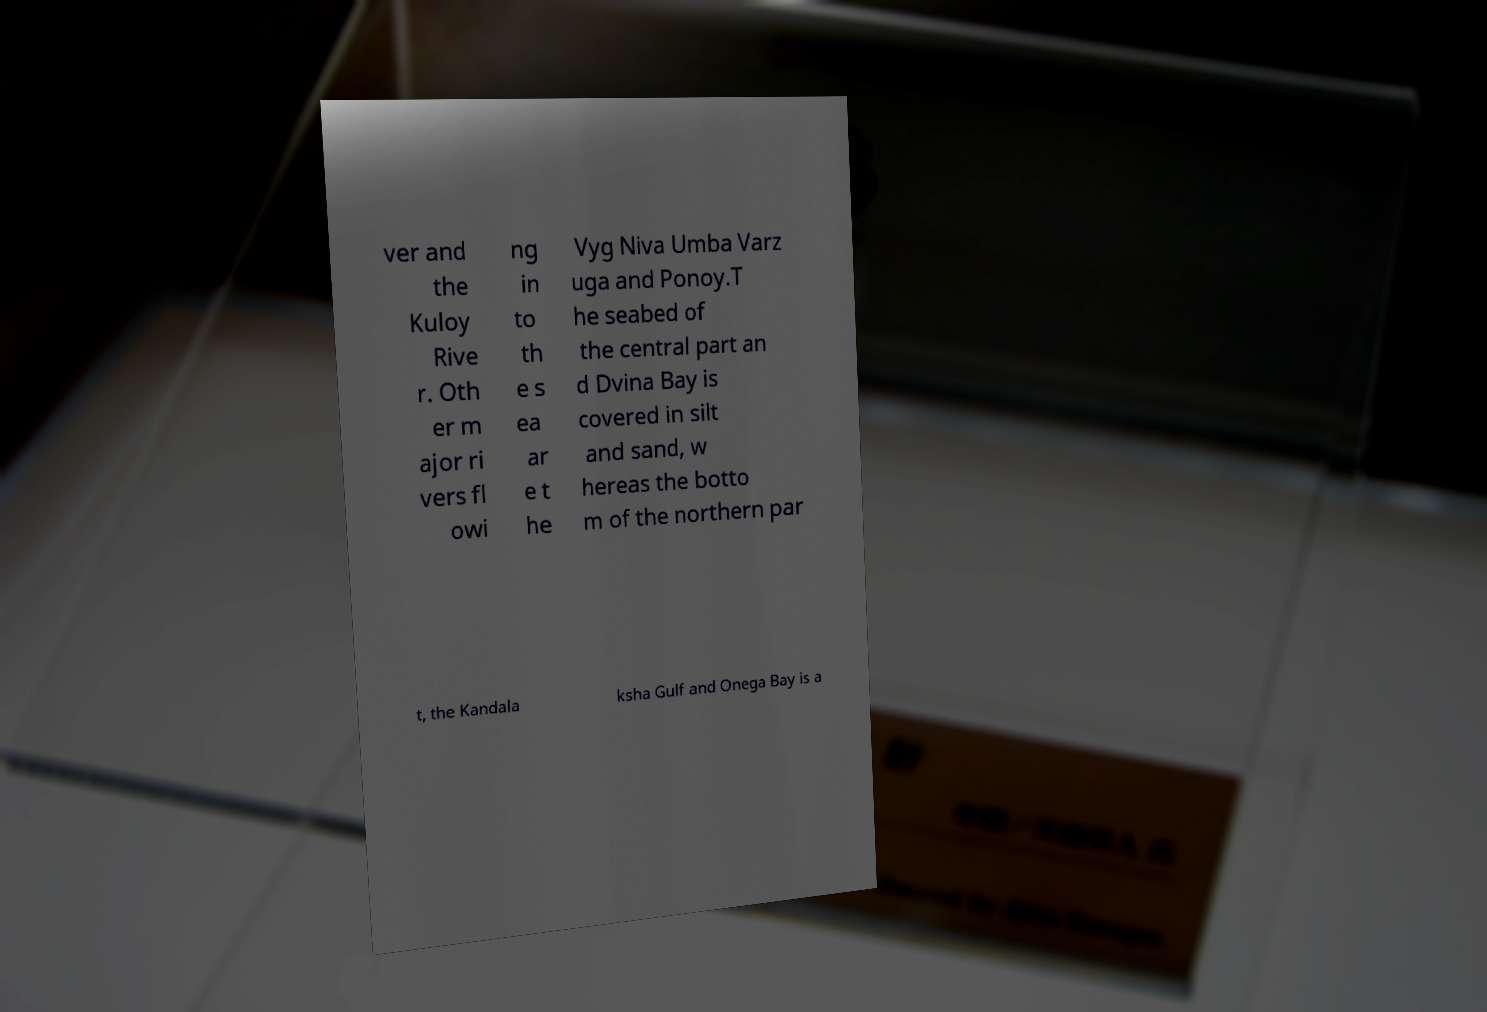What messages or text are displayed in this image? I need them in a readable, typed format. ver and the Kuloy Rive r. Oth er m ajor ri vers fl owi ng in to th e s ea ar e t he Vyg Niva Umba Varz uga and Ponoy.T he seabed of the central part an d Dvina Bay is covered in silt and sand, w hereas the botto m of the northern par t, the Kandala ksha Gulf and Onega Bay is a 